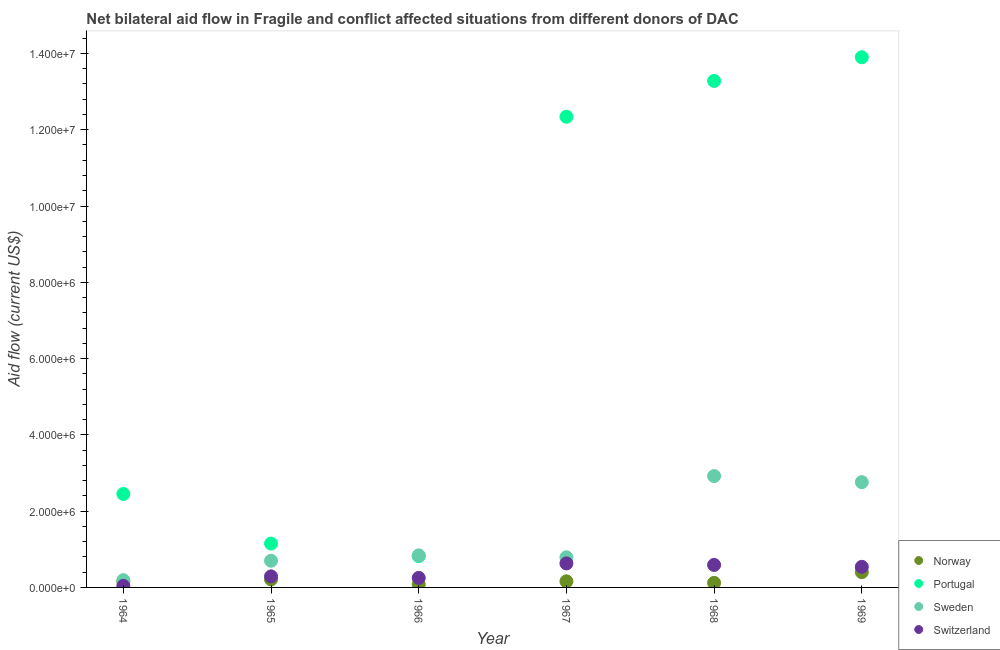What is the amount of aid given by portugal in 1968?
Your response must be concise. 1.33e+07. Across all years, what is the maximum amount of aid given by sweden?
Ensure brevity in your answer.  2.92e+06. Across all years, what is the minimum amount of aid given by portugal?
Make the answer very short. 8.20e+05. In which year was the amount of aid given by switzerland maximum?
Offer a terse response. 1967. In which year was the amount of aid given by norway minimum?
Your response must be concise. 1966. What is the total amount of aid given by sweden in the graph?
Make the answer very short. 8.20e+06. What is the difference between the amount of aid given by norway in 1967 and that in 1968?
Provide a succinct answer. 4.00e+04. What is the difference between the amount of aid given by sweden in 1965 and the amount of aid given by portugal in 1964?
Make the answer very short. -1.75e+06. In the year 1965, what is the difference between the amount of aid given by portugal and amount of aid given by sweden?
Your response must be concise. 4.50e+05. In how many years, is the amount of aid given by switzerland greater than 3600000 US$?
Make the answer very short. 0. What is the ratio of the amount of aid given by sweden in 1967 to that in 1968?
Offer a terse response. 0.27. Is the amount of aid given by portugal in 1967 less than that in 1969?
Your answer should be compact. Yes. What is the difference between the highest and the lowest amount of aid given by norway?
Offer a very short reply. 3.20e+05. Is the sum of the amount of aid given by sweden in 1964 and 1967 greater than the maximum amount of aid given by portugal across all years?
Offer a very short reply. No. Does the amount of aid given by portugal monotonically increase over the years?
Provide a short and direct response. No. Is the amount of aid given by sweden strictly greater than the amount of aid given by norway over the years?
Make the answer very short. Yes. Is the amount of aid given by sweden strictly less than the amount of aid given by portugal over the years?
Provide a short and direct response. No. How many dotlines are there?
Make the answer very short. 4. What is the difference between two consecutive major ticks on the Y-axis?
Keep it short and to the point. 2.00e+06. Does the graph contain any zero values?
Your response must be concise. No. Does the graph contain grids?
Your response must be concise. No. Where does the legend appear in the graph?
Keep it short and to the point. Bottom right. What is the title of the graph?
Your answer should be compact. Net bilateral aid flow in Fragile and conflict affected situations from different donors of DAC. Does "Portugal" appear as one of the legend labels in the graph?
Ensure brevity in your answer.  Yes. What is the label or title of the Y-axis?
Your answer should be very brief. Aid flow (current US$). What is the Aid flow (current US$) in Norway in 1964?
Give a very brief answer. 1.60e+05. What is the Aid flow (current US$) of Portugal in 1964?
Provide a short and direct response. 2.45e+06. What is the Aid flow (current US$) of Sweden in 1964?
Offer a terse response. 1.90e+05. What is the Aid flow (current US$) in Portugal in 1965?
Ensure brevity in your answer.  1.15e+06. What is the Aid flow (current US$) of Norway in 1966?
Keep it short and to the point. 8.00e+04. What is the Aid flow (current US$) in Portugal in 1966?
Provide a succinct answer. 8.20e+05. What is the Aid flow (current US$) of Sweden in 1966?
Keep it short and to the point. 8.40e+05. What is the Aid flow (current US$) in Portugal in 1967?
Offer a terse response. 1.23e+07. What is the Aid flow (current US$) of Sweden in 1967?
Offer a terse response. 7.90e+05. What is the Aid flow (current US$) of Switzerland in 1967?
Give a very brief answer. 6.30e+05. What is the Aid flow (current US$) in Portugal in 1968?
Keep it short and to the point. 1.33e+07. What is the Aid flow (current US$) in Sweden in 1968?
Keep it short and to the point. 2.92e+06. What is the Aid flow (current US$) of Switzerland in 1968?
Ensure brevity in your answer.  5.90e+05. What is the Aid flow (current US$) of Portugal in 1969?
Give a very brief answer. 1.39e+07. What is the Aid flow (current US$) of Sweden in 1969?
Give a very brief answer. 2.76e+06. What is the Aid flow (current US$) in Switzerland in 1969?
Your response must be concise. 5.40e+05. Across all years, what is the maximum Aid flow (current US$) of Norway?
Offer a terse response. 4.00e+05. Across all years, what is the maximum Aid flow (current US$) in Portugal?
Your answer should be very brief. 1.39e+07. Across all years, what is the maximum Aid flow (current US$) of Sweden?
Make the answer very short. 2.92e+06. Across all years, what is the maximum Aid flow (current US$) of Switzerland?
Give a very brief answer. 6.30e+05. Across all years, what is the minimum Aid flow (current US$) in Portugal?
Offer a very short reply. 8.20e+05. Across all years, what is the minimum Aid flow (current US$) of Switzerland?
Ensure brevity in your answer.  4.00e+04. What is the total Aid flow (current US$) of Norway in the graph?
Your answer should be compact. 1.13e+06. What is the total Aid flow (current US$) of Portugal in the graph?
Provide a short and direct response. 4.39e+07. What is the total Aid flow (current US$) of Sweden in the graph?
Offer a very short reply. 8.20e+06. What is the total Aid flow (current US$) of Switzerland in the graph?
Ensure brevity in your answer.  2.34e+06. What is the difference between the Aid flow (current US$) in Norway in 1964 and that in 1965?
Provide a short and direct response. -5.00e+04. What is the difference between the Aid flow (current US$) of Portugal in 1964 and that in 1965?
Provide a succinct answer. 1.30e+06. What is the difference between the Aid flow (current US$) in Sweden in 1964 and that in 1965?
Offer a very short reply. -5.10e+05. What is the difference between the Aid flow (current US$) in Norway in 1964 and that in 1966?
Provide a short and direct response. 8.00e+04. What is the difference between the Aid flow (current US$) in Portugal in 1964 and that in 1966?
Make the answer very short. 1.63e+06. What is the difference between the Aid flow (current US$) in Sweden in 1964 and that in 1966?
Provide a succinct answer. -6.50e+05. What is the difference between the Aid flow (current US$) in Portugal in 1964 and that in 1967?
Offer a very short reply. -9.89e+06. What is the difference between the Aid flow (current US$) in Sweden in 1964 and that in 1967?
Your answer should be compact. -6.00e+05. What is the difference between the Aid flow (current US$) in Switzerland in 1964 and that in 1967?
Your answer should be compact. -5.90e+05. What is the difference between the Aid flow (current US$) of Norway in 1964 and that in 1968?
Give a very brief answer. 4.00e+04. What is the difference between the Aid flow (current US$) in Portugal in 1964 and that in 1968?
Keep it short and to the point. -1.08e+07. What is the difference between the Aid flow (current US$) in Sweden in 1964 and that in 1968?
Your response must be concise. -2.73e+06. What is the difference between the Aid flow (current US$) of Switzerland in 1964 and that in 1968?
Your answer should be compact. -5.50e+05. What is the difference between the Aid flow (current US$) in Norway in 1964 and that in 1969?
Ensure brevity in your answer.  -2.40e+05. What is the difference between the Aid flow (current US$) in Portugal in 1964 and that in 1969?
Provide a short and direct response. -1.14e+07. What is the difference between the Aid flow (current US$) in Sweden in 1964 and that in 1969?
Offer a very short reply. -2.57e+06. What is the difference between the Aid flow (current US$) of Switzerland in 1964 and that in 1969?
Ensure brevity in your answer.  -5.00e+05. What is the difference between the Aid flow (current US$) of Switzerland in 1965 and that in 1966?
Provide a succinct answer. 4.00e+04. What is the difference between the Aid flow (current US$) of Norway in 1965 and that in 1967?
Offer a terse response. 5.00e+04. What is the difference between the Aid flow (current US$) of Portugal in 1965 and that in 1967?
Ensure brevity in your answer.  -1.12e+07. What is the difference between the Aid flow (current US$) of Portugal in 1965 and that in 1968?
Offer a terse response. -1.21e+07. What is the difference between the Aid flow (current US$) of Sweden in 1965 and that in 1968?
Keep it short and to the point. -2.22e+06. What is the difference between the Aid flow (current US$) in Switzerland in 1965 and that in 1968?
Your answer should be very brief. -3.00e+05. What is the difference between the Aid flow (current US$) in Portugal in 1965 and that in 1969?
Ensure brevity in your answer.  -1.28e+07. What is the difference between the Aid flow (current US$) of Sweden in 1965 and that in 1969?
Make the answer very short. -2.06e+06. What is the difference between the Aid flow (current US$) in Norway in 1966 and that in 1967?
Offer a terse response. -8.00e+04. What is the difference between the Aid flow (current US$) of Portugal in 1966 and that in 1967?
Your response must be concise. -1.15e+07. What is the difference between the Aid flow (current US$) of Sweden in 1966 and that in 1967?
Your answer should be compact. 5.00e+04. What is the difference between the Aid flow (current US$) of Switzerland in 1966 and that in 1967?
Offer a very short reply. -3.80e+05. What is the difference between the Aid flow (current US$) in Portugal in 1966 and that in 1968?
Give a very brief answer. -1.25e+07. What is the difference between the Aid flow (current US$) of Sweden in 1966 and that in 1968?
Make the answer very short. -2.08e+06. What is the difference between the Aid flow (current US$) of Norway in 1966 and that in 1969?
Provide a short and direct response. -3.20e+05. What is the difference between the Aid flow (current US$) of Portugal in 1966 and that in 1969?
Offer a very short reply. -1.31e+07. What is the difference between the Aid flow (current US$) in Sweden in 1966 and that in 1969?
Your answer should be very brief. -1.92e+06. What is the difference between the Aid flow (current US$) of Switzerland in 1966 and that in 1969?
Provide a succinct answer. -2.90e+05. What is the difference between the Aid flow (current US$) in Portugal in 1967 and that in 1968?
Offer a terse response. -9.40e+05. What is the difference between the Aid flow (current US$) in Sweden in 1967 and that in 1968?
Provide a succinct answer. -2.13e+06. What is the difference between the Aid flow (current US$) of Norway in 1967 and that in 1969?
Offer a very short reply. -2.40e+05. What is the difference between the Aid flow (current US$) of Portugal in 1967 and that in 1969?
Ensure brevity in your answer.  -1.56e+06. What is the difference between the Aid flow (current US$) of Sweden in 1967 and that in 1969?
Provide a short and direct response. -1.97e+06. What is the difference between the Aid flow (current US$) in Switzerland in 1967 and that in 1969?
Your answer should be very brief. 9.00e+04. What is the difference between the Aid flow (current US$) in Norway in 1968 and that in 1969?
Ensure brevity in your answer.  -2.80e+05. What is the difference between the Aid flow (current US$) in Portugal in 1968 and that in 1969?
Keep it short and to the point. -6.20e+05. What is the difference between the Aid flow (current US$) of Sweden in 1968 and that in 1969?
Your answer should be very brief. 1.60e+05. What is the difference between the Aid flow (current US$) of Switzerland in 1968 and that in 1969?
Your response must be concise. 5.00e+04. What is the difference between the Aid flow (current US$) in Norway in 1964 and the Aid flow (current US$) in Portugal in 1965?
Your answer should be very brief. -9.90e+05. What is the difference between the Aid flow (current US$) of Norway in 1964 and the Aid flow (current US$) of Sweden in 1965?
Ensure brevity in your answer.  -5.40e+05. What is the difference between the Aid flow (current US$) in Portugal in 1964 and the Aid flow (current US$) in Sweden in 1965?
Give a very brief answer. 1.75e+06. What is the difference between the Aid flow (current US$) of Portugal in 1964 and the Aid flow (current US$) of Switzerland in 1965?
Ensure brevity in your answer.  2.16e+06. What is the difference between the Aid flow (current US$) of Norway in 1964 and the Aid flow (current US$) of Portugal in 1966?
Your response must be concise. -6.60e+05. What is the difference between the Aid flow (current US$) in Norway in 1964 and the Aid flow (current US$) in Sweden in 1966?
Keep it short and to the point. -6.80e+05. What is the difference between the Aid flow (current US$) in Portugal in 1964 and the Aid flow (current US$) in Sweden in 1966?
Keep it short and to the point. 1.61e+06. What is the difference between the Aid flow (current US$) of Portugal in 1964 and the Aid flow (current US$) of Switzerland in 1966?
Your response must be concise. 2.20e+06. What is the difference between the Aid flow (current US$) in Sweden in 1964 and the Aid flow (current US$) in Switzerland in 1966?
Offer a very short reply. -6.00e+04. What is the difference between the Aid flow (current US$) in Norway in 1964 and the Aid flow (current US$) in Portugal in 1967?
Your answer should be very brief. -1.22e+07. What is the difference between the Aid flow (current US$) of Norway in 1964 and the Aid flow (current US$) of Sweden in 1967?
Offer a very short reply. -6.30e+05. What is the difference between the Aid flow (current US$) in Norway in 1964 and the Aid flow (current US$) in Switzerland in 1967?
Your response must be concise. -4.70e+05. What is the difference between the Aid flow (current US$) in Portugal in 1964 and the Aid flow (current US$) in Sweden in 1967?
Offer a terse response. 1.66e+06. What is the difference between the Aid flow (current US$) of Portugal in 1964 and the Aid flow (current US$) of Switzerland in 1967?
Your answer should be very brief. 1.82e+06. What is the difference between the Aid flow (current US$) of Sweden in 1964 and the Aid flow (current US$) of Switzerland in 1967?
Your answer should be compact. -4.40e+05. What is the difference between the Aid flow (current US$) of Norway in 1964 and the Aid flow (current US$) of Portugal in 1968?
Provide a succinct answer. -1.31e+07. What is the difference between the Aid flow (current US$) of Norway in 1964 and the Aid flow (current US$) of Sweden in 1968?
Your response must be concise. -2.76e+06. What is the difference between the Aid flow (current US$) of Norway in 1964 and the Aid flow (current US$) of Switzerland in 1968?
Ensure brevity in your answer.  -4.30e+05. What is the difference between the Aid flow (current US$) of Portugal in 1964 and the Aid flow (current US$) of Sweden in 1968?
Ensure brevity in your answer.  -4.70e+05. What is the difference between the Aid flow (current US$) of Portugal in 1964 and the Aid flow (current US$) of Switzerland in 1968?
Provide a succinct answer. 1.86e+06. What is the difference between the Aid flow (current US$) of Sweden in 1964 and the Aid flow (current US$) of Switzerland in 1968?
Your answer should be very brief. -4.00e+05. What is the difference between the Aid flow (current US$) of Norway in 1964 and the Aid flow (current US$) of Portugal in 1969?
Your response must be concise. -1.37e+07. What is the difference between the Aid flow (current US$) in Norway in 1964 and the Aid flow (current US$) in Sweden in 1969?
Give a very brief answer. -2.60e+06. What is the difference between the Aid flow (current US$) in Norway in 1964 and the Aid flow (current US$) in Switzerland in 1969?
Ensure brevity in your answer.  -3.80e+05. What is the difference between the Aid flow (current US$) in Portugal in 1964 and the Aid flow (current US$) in Sweden in 1969?
Ensure brevity in your answer.  -3.10e+05. What is the difference between the Aid flow (current US$) in Portugal in 1964 and the Aid flow (current US$) in Switzerland in 1969?
Your response must be concise. 1.91e+06. What is the difference between the Aid flow (current US$) of Sweden in 1964 and the Aid flow (current US$) of Switzerland in 1969?
Offer a very short reply. -3.50e+05. What is the difference between the Aid flow (current US$) in Norway in 1965 and the Aid flow (current US$) in Portugal in 1966?
Your response must be concise. -6.10e+05. What is the difference between the Aid flow (current US$) of Norway in 1965 and the Aid flow (current US$) of Sweden in 1966?
Make the answer very short. -6.30e+05. What is the difference between the Aid flow (current US$) of Norway in 1965 and the Aid flow (current US$) of Switzerland in 1966?
Offer a very short reply. -4.00e+04. What is the difference between the Aid flow (current US$) of Portugal in 1965 and the Aid flow (current US$) of Switzerland in 1966?
Your response must be concise. 9.00e+05. What is the difference between the Aid flow (current US$) in Norway in 1965 and the Aid flow (current US$) in Portugal in 1967?
Offer a terse response. -1.21e+07. What is the difference between the Aid flow (current US$) of Norway in 1965 and the Aid flow (current US$) of Sweden in 1967?
Give a very brief answer. -5.80e+05. What is the difference between the Aid flow (current US$) in Norway in 1965 and the Aid flow (current US$) in Switzerland in 1967?
Your response must be concise. -4.20e+05. What is the difference between the Aid flow (current US$) in Portugal in 1965 and the Aid flow (current US$) in Sweden in 1967?
Give a very brief answer. 3.60e+05. What is the difference between the Aid flow (current US$) of Portugal in 1965 and the Aid flow (current US$) of Switzerland in 1967?
Give a very brief answer. 5.20e+05. What is the difference between the Aid flow (current US$) of Sweden in 1965 and the Aid flow (current US$) of Switzerland in 1967?
Your answer should be very brief. 7.00e+04. What is the difference between the Aid flow (current US$) in Norway in 1965 and the Aid flow (current US$) in Portugal in 1968?
Offer a very short reply. -1.31e+07. What is the difference between the Aid flow (current US$) of Norway in 1965 and the Aid flow (current US$) of Sweden in 1968?
Offer a terse response. -2.71e+06. What is the difference between the Aid flow (current US$) in Norway in 1965 and the Aid flow (current US$) in Switzerland in 1968?
Keep it short and to the point. -3.80e+05. What is the difference between the Aid flow (current US$) of Portugal in 1965 and the Aid flow (current US$) of Sweden in 1968?
Provide a short and direct response. -1.77e+06. What is the difference between the Aid flow (current US$) in Portugal in 1965 and the Aid flow (current US$) in Switzerland in 1968?
Your answer should be very brief. 5.60e+05. What is the difference between the Aid flow (current US$) of Norway in 1965 and the Aid flow (current US$) of Portugal in 1969?
Your response must be concise. -1.37e+07. What is the difference between the Aid flow (current US$) of Norway in 1965 and the Aid flow (current US$) of Sweden in 1969?
Your answer should be compact. -2.55e+06. What is the difference between the Aid flow (current US$) of Norway in 1965 and the Aid flow (current US$) of Switzerland in 1969?
Keep it short and to the point. -3.30e+05. What is the difference between the Aid flow (current US$) of Portugal in 1965 and the Aid flow (current US$) of Sweden in 1969?
Provide a succinct answer. -1.61e+06. What is the difference between the Aid flow (current US$) in Portugal in 1965 and the Aid flow (current US$) in Switzerland in 1969?
Make the answer very short. 6.10e+05. What is the difference between the Aid flow (current US$) in Norway in 1966 and the Aid flow (current US$) in Portugal in 1967?
Your answer should be very brief. -1.23e+07. What is the difference between the Aid flow (current US$) of Norway in 1966 and the Aid flow (current US$) of Sweden in 1967?
Offer a very short reply. -7.10e+05. What is the difference between the Aid flow (current US$) of Norway in 1966 and the Aid flow (current US$) of Switzerland in 1967?
Your answer should be very brief. -5.50e+05. What is the difference between the Aid flow (current US$) of Portugal in 1966 and the Aid flow (current US$) of Sweden in 1967?
Ensure brevity in your answer.  3.00e+04. What is the difference between the Aid flow (current US$) in Sweden in 1966 and the Aid flow (current US$) in Switzerland in 1967?
Offer a very short reply. 2.10e+05. What is the difference between the Aid flow (current US$) of Norway in 1966 and the Aid flow (current US$) of Portugal in 1968?
Give a very brief answer. -1.32e+07. What is the difference between the Aid flow (current US$) of Norway in 1966 and the Aid flow (current US$) of Sweden in 1968?
Your response must be concise. -2.84e+06. What is the difference between the Aid flow (current US$) of Norway in 1966 and the Aid flow (current US$) of Switzerland in 1968?
Give a very brief answer. -5.10e+05. What is the difference between the Aid flow (current US$) in Portugal in 1966 and the Aid flow (current US$) in Sweden in 1968?
Keep it short and to the point. -2.10e+06. What is the difference between the Aid flow (current US$) of Portugal in 1966 and the Aid flow (current US$) of Switzerland in 1968?
Provide a short and direct response. 2.30e+05. What is the difference between the Aid flow (current US$) of Norway in 1966 and the Aid flow (current US$) of Portugal in 1969?
Offer a terse response. -1.38e+07. What is the difference between the Aid flow (current US$) of Norway in 1966 and the Aid flow (current US$) of Sweden in 1969?
Offer a very short reply. -2.68e+06. What is the difference between the Aid flow (current US$) of Norway in 1966 and the Aid flow (current US$) of Switzerland in 1969?
Your response must be concise. -4.60e+05. What is the difference between the Aid flow (current US$) in Portugal in 1966 and the Aid flow (current US$) in Sweden in 1969?
Keep it short and to the point. -1.94e+06. What is the difference between the Aid flow (current US$) of Sweden in 1966 and the Aid flow (current US$) of Switzerland in 1969?
Offer a very short reply. 3.00e+05. What is the difference between the Aid flow (current US$) of Norway in 1967 and the Aid flow (current US$) of Portugal in 1968?
Your answer should be compact. -1.31e+07. What is the difference between the Aid flow (current US$) of Norway in 1967 and the Aid flow (current US$) of Sweden in 1968?
Your response must be concise. -2.76e+06. What is the difference between the Aid flow (current US$) in Norway in 1967 and the Aid flow (current US$) in Switzerland in 1968?
Offer a very short reply. -4.30e+05. What is the difference between the Aid flow (current US$) in Portugal in 1967 and the Aid flow (current US$) in Sweden in 1968?
Offer a very short reply. 9.42e+06. What is the difference between the Aid flow (current US$) in Portugal in 1967 and the Aid flow (current US$) in Switzerland in 1968?
Make the answer very short. 1.18e+07. What is the difference between the Aid flow (current US$) of Sweden in 1967 and the Aid flow (current US$) of Switzerland in 1968?
Offer a terse response. 2.00e+05. What is the difference between the Aid flow (current US$) in Norway in 1967 and the Aid flow (current US$) in Portugal in 1969?
Provide a succinct answer. -1.37e+07. What is the difference between the Aid flow (current US$) in Norway in 1967 and the Aid flow (current US$) in Sweden in 1969?
Offer a very short reply. -2.60e+06. What is the difference between the Aid flow (current US$) in Norway in 1967 and the Aid flow (current US$) in Switzerland in 1969?
Your response must be concise. -3.80e+05. What is the difference between the Aid flow (current US$) in Portugal in 1967 and the Aid flow (current US$) in Sweden in 1969?
Offer a terse response. 9.58e+06. What is the difference between the Aid flow (current US$) of Portugal in 1967 and the Aid flow (current US$) of Switzerland in 1969?
Ensure brevity in your answer.  1.18e+07. What is the difference between the Aid flow (current US$) in Norway in 1968 and the Aid flow (current US$) in Portugal in 1969?
Provide a short and direct response. -1.38e+07. What is the difference between the Aid flow (current US$) of Norway in 1968 and the Aid flow (current US$) of Sweden in 1969?
Make the answer very short. -2.64e+06. What is the difference between the Aid flow (current US$) of Norway in 1968 and the Aid flow (current US$) of Switzerland in 1969?
Your answer should be very brief. -4.20e+05. What is the difference between the Aid flow (current US$) in Portugal in 1968 and the Aid flow (current US$) in Sweden in 1969?
Make the answer very short. 1.05e+07. What is the difference between the Aid flow (current US$) in Portugal in 1968 and the Aid flow (current US$) in Switzerland in 1969?
Your response must be concise. 1.27e+07. What is the difference between the Aid flow (current US$) in Sweden in 1968 and the Aid flow (current US$) in Switzerland in 1969?
Make the answer very short. 2.38e+06. What is the average Aid flow (current US$) in Norway per year?
Offer a very short reply. 1.88e+05. What is the average Aid flow (current US$) of Portugal per year?
Ensure brevity in your answer.  7.32e+06. What is the average Aid flow (current US$) in Sweden per year?
Ensure brevity in your answer.  1.37e+06. In the year 1964, what is the difference between the Aid flow (current US$) of Norway and Aid flow (current US$) of Portugal?
Your response must be concise. -2.29e+06. In the year 1964, what is the difference between the Aid flow (current US$) in Portugal and Aid flow (current US$) in Sweden?
Give a very brief answer. 2.26e+06. In the year 1964, what is the difference between the Aid flow (current US$) in Portugal and Aid flow (current US$) in Switzerland?
Provide a short and direct response. 2.41e+06. In the year 1965, what is the difference between the Aid flow (current US$) in Norway and Aid flow (current US$) in Portugal?
Your answer should be compact. -9.40e+05. In the year 1965, what is the difference between the Aid flow (current US$) in Norway and Aid flow (current US$) in Sweden?
Make the answer very short. -4.90e+05. In the year 1965, what is the difference between the Aid flow (current US$) of Norway and Aid flow (current US$) of Switzerland?
Your answer should be compact. -8.00e+04. In the year 1965, what is the difference between the Aid flow (current US$) in Portugal and Aid flow (current US$) in Sweden?
Make the answer very short. 4.50e+05. In the year 1965, what is the difference between the Aid flow (current US$) of Portugal and Aid flow (current US$) of Switzerland?
Offer a very short reply. 8.60e+05. In the year 1966, what is the difference between the Aid flow (current US$) in Norway and Aid flow (current US$) in Portugal?
Your answer should be very brief. -7.40e+05. In the year 1966, what is the difference between the Aid flow (current US$) in Norway and Aid flow (current US$) in Sweden?
Keep it short and to the point. -7.60e+05. In the year 1966, what is the difference between the Aid flow (current US$) in Portugal and Aid flow (current US$) in Sweden?
Provide a short and direct response. -2.00e+04. In the year 1966, what is the difference between the Aid flow (current US$) in Portugal and Aid flow (current US$) in Switzerland?
Make the answer very short. 5.70e+05. In the year 1966, what is the difference between the Aid flow (current US$) of Sweden and Aid flow (current US$) of Switzerland?
Your answer should be compact. 5.90e+05. In the year 1967, what is the difference between the Aid flow (current US$) of Norway and Aid flow (current US$) of Portugal?
Offer a terse response. -1.22e+07. In the year 1967, what is the difference between the Aid flow (current US$) of Norway and Aid flow (current US$) of Sweden?
Your response must be concise. -6.30e+05. In the year 1967, what is the difference between the Aid flow (current US$) of Norway and Aid flow (current US$) of Switzerland?
Provide a succinct answer. -4.70e+05. In the year 1967, what is the difference between the Aid flow (current US$) in Portugal and Aid flow (current US$) in Sweden?
Offer a terse response. 1.16e+07. In the year 1967, what is the difference between the Aid flow (current US$) in Portugal and Aid flow (current US$) in Switzerland?
Give a very brief answer. 1.17e+07. In the year 1968, what is the difference between the Aid flow (current US$) of Norway and Aid flow (current US$) of Portugal?
Ensure brevity in your answer.  -1.32e+07. In the year 1968, what is the difference between the Aid flow (current US$) in Norway and Aid flow (current US$) in Sweden?
Provide a succinct answer. -2.80e+06. In the year 1968, what is the difference between the Aid flow (current US$) of Norway and Aid flow (current US$) of Switzerland?
Provide a succinct answer. -4.70e+05. In the year 1968, what is the difference between the Aid flow (current US$) of Portugal and Aid flow (current US$) of Sweden?
Make the answer very short. 1.04e+07. In the year 1968, what is the difference between the Aid flow (current US$) of Portugal and Aid flow (current US$) of Switzerland?
Give a very brief answer. 1.27e+07. In the year 1968, what is the difference between the Aid flow (current US$) of Sweden and Aid flow (current US$) of Switzerland?
Your answer should be compact. 2.33e+06. In the year 1969, what is the difference between the Aid flow (current US$) of Norway and Aid flow (current US$) of Portugal?
Offer a terse response. -1.35e+07. In the year 1969, what is the difference between the Aid flow (current US$) in Norway and Aid flow (current US$) in Sweden?
Provide a short and direct response. -2.36e+06. In the year 1969, what is the difference between the Aid flow (current US$) of Portugal and Aid flow (current US$) of Sweden?
Ensure brevity in your answer.  1.11e+07. In the year 1969, what is the difference between the Aid flow (current US$) in Portugal and Aid flow (current US$) in Switzerland?
Make the answer very short. 1.34e+07. In the year 1969, what is the difference between the Aid flow (current US$) of Sweden and Aid flow (current US$) of Switzerland?
Give a very brief answer. 2.22e+06. What is the ratio of the Aid flow (current US$) of Norway in 1964 to that in 1965?
Give a very brief answer. 0.76. What is the ratio of the Aid flow (current US$) in Portugal in 1964 to that in 1965?
Make the answer very short. 2.13. What is the ratio of the Aid flow (current US$) in Sweden in 1964 to that in 1965?
Your answer should be compact. 0.27. What is the ratio of the Aid flow (current US$) of Switzerland in 1964 to that in 1965?
Offer a very short reply. 0.14. What is the ratio of the Aid flow (current US$) in Portugal in 1964 to that in 1966?
Provide a succinct answer. 2.99. What is the ratio of the Aid flow (current US$) in Sweden in 1964 to that in 1966?
Provide a short and direct response. 0.23. What is the ratio of the Aid flow (current US$) of Switzerland in 1964 to that in 1966?
Your answer should be compact. 0.16. What is the ratio of the Aid flow (current US$) in Norway in 1964 to that in 1967?
Give a very brief answer. 1. What is the ratio of the Aid flow (current US$) in Portugal in 1964 to that in 1967?
Offer a very short reply. 0.2. What is the ratio of the Aid flow (current US$) in Sweden in 1964 to that in 1967?
Keep it short and to the point. 0.24. What is the ratio of the Aid flow (current US$) in Switzerland in 1964 to that in 1967?
Give a very brief answer. 0.06. What is the ratio of the Aid flow (current US$) in Norway in 1964 to that in 1968?
Your answer should be compact. 1.33. What is the ratio of the Aid flow (current US$) in Portugal in 1964 to that in 1968?
Your response must be concise. 0.18. What is the ratio of the Aid flow (current US$) of Sweden in 1964 to that in 1968?
Keep it short and to the point. 0.07. What is the ratio of the Aid flow (current US$) of Switzerland in 1964 to that in 1968?
Your answer should be compact. 0.07. What is the ratio of the Aid flow (current US$) in Portugal in 1964 to that in 1969?
Provide a short and direct response. 0.18. What is the ratio of the Aid flow (current US$) in Sweden in 1964 to that in 1969?
Offer a very short reply. 0.07. What is the ratio of the Aid flow (current US$) in Switzerland in 1964 to that in 1969?
Provide a succinct answer. 0.07. What is the ratio of the Aid flow (current US$) of Norway in 1965 to that in 1966?
Your response must be concise. 2.62. What is the ratio of the Aid flow (current US$) in Portugal in 1965 to that in 1966?
Your answer should be compact. 1.4. What is the ratio of the Aid flow (current US$) of Switzerland in 1965 to that in 1966?
Offer a very short reply. 1.16. What is the ratio of the Aid flow (current US$) in Norway in 1965 to that in 1967?
Make the answer very short. 1.31. What is the ratio of the Aid flow (current US$) in Portugal in 1965 to that in 1967?
Your answer should be compact. 0.09. What is the ratio of the Aid flow (current US$) in Sweden in 1965 to that in 1967?
Offer a very short reply. 0.89. What is the ratio of the Aid flow (current US$) of Switzerland in 1965 to that in 1967?
Your response must be concise. 0.46. What is the ratio of the Aid flow (current US$) in Norway in 1965 to that in 1968?
Provide a succinct answer. 1.75. What is the ratio of the Aid flow (current US$) in Portugal in 1965 to that in 1968?
Provide a short and direct response. 0.09. What is the ratio of the Aid flow (current US$) in Sweden in 1965 to that in 1968?
Keep it short and to the point. 0.24. What is the ratio of the Aid flow (current US$) in Switzerland in 1965 to that in 1968?
Your response must be concise. 0.49. What is the ratio of the Aid flow (current US$) in Norway in 1965 to that in 1969?
Provide a short and direct response. 0.53. What is the ratio of the Aid flow (current US$) of Portugal in 1965 to that in 1969?
Keep it short and to the point. 0.08. What is the ratio of the Aid flow (current US$) in Sweden in 1965 to that in 1969?
Ensure brevity in your answer.  0.25. What is the ratio of the Aid flow (current US$) of Switzerland in 1965 to that in 1969?
Provide a short and direct response. 0.54. What is the ratio of the Aid flow (current US$) of Portugal in 1966 to that in 1967?
Give a very brief answer. 0.07. What is the ratio of the Aid flow (current US$) of Sweden in 1966 to that in 1967?
Make the answer very short. 1.06. What is the ratio of the Aid flow (current US$) in Switzerland in 1966 to that in 1967?
Your answer should be compact. 0.4. What is the ratio of the Aid flow (current US$) in Norway in 1966 to that in 1968?
Your answer should be very brief. 0.67. What is the ratio of the Aid flow (current US$) in Portugal in 1966 to that in 1968?
Your answer should be very brief. 0.06. What is the ratio of the Aid flow (current US$) in Sweden in 1966 to that in 1968?
Your response must be concise. 0.29. What is the ratio of the Aid flow (current US$) in Switzerland in 1966 to that in 1968?
Your response must be concise. 0.42. What is the ratio of the Aid flow (current US$) of Portugal in 1966 to that in 1969?
Keep it short and to the point. 0.06. What is the ratio of the Aid flow (current US$) of Sweden in 1966 to that in 1969?
Make the answer very short. 0.3. What is the ratio of the Aid flow (current US$) of Switzerland in 1966 to that in 1969?
Your response must be concise. 0.46. What is the ratio of the Aid flow (current US$) in Norway in 1967 to that in 1968?
Ensure brevity in your answer.  1.33. What is the ratio of the Aid flow (current US$) in Portugal in 1967 to that in 1968?
Ensure brevity in your answer.  0.93. What is the ratio of the Aid flow (current US$) in Sweden in 1967 to that in 1968?
Your answer should be compact. 0.27. What is the ratio of the Aid flow (current US$) in Switzerland in 1967 to that in 1968?
Ensure brevity in your answer.  1.07. What is the ratio of the Aid flow (current US$) of Portugal in 1967 to that in 1969?
Your answer should be very brief. 0.89. What is the ratio of the Aid flow (current US$) of Sweden in 1967 to that in 1969?
Provide a short and direct response. 0.29. What is the ratio of the Aid flow (current US$) of Norway in 1968 to that in 1969?
Offer a very short reply. 0.3. What is the ratio of the Aid flow (current US$) in Portugal in 1968 to that in 1969?
Give a very brief answer. 0.96. What is the ratio of the Aid flow (current US$) in Sweden in 1968 to that in 1969?
Your response must be concise. 1.06. What is the ratio of the Aid flow (current US$) in Switzerland in 1968 to that in 1969?
Ensure brevity in your answer.  1.09. What is the difference between the highest and the second highest Aid flow (current US$) of Portugal?
Keep it short and to the point. 6.20e+05. What is the difference between the highest and the second highest Aid flow (current US$) in Sweden?
Provide a short and direct response. 1.60e+05. What is the difference between the highest and the lowest Aid flow (current US$) of Portugal?
Offer a very short reply. 1.31e+07. What is the difference between the highest and the lowest Aid flow (current US$) in Sweden?
Give a very brief answer. 2.73e+06. What is the difference between the highest and the lowest Aid flow (current US$) in Switzerland?
Your answer should be very brief. 5.90e+05. 